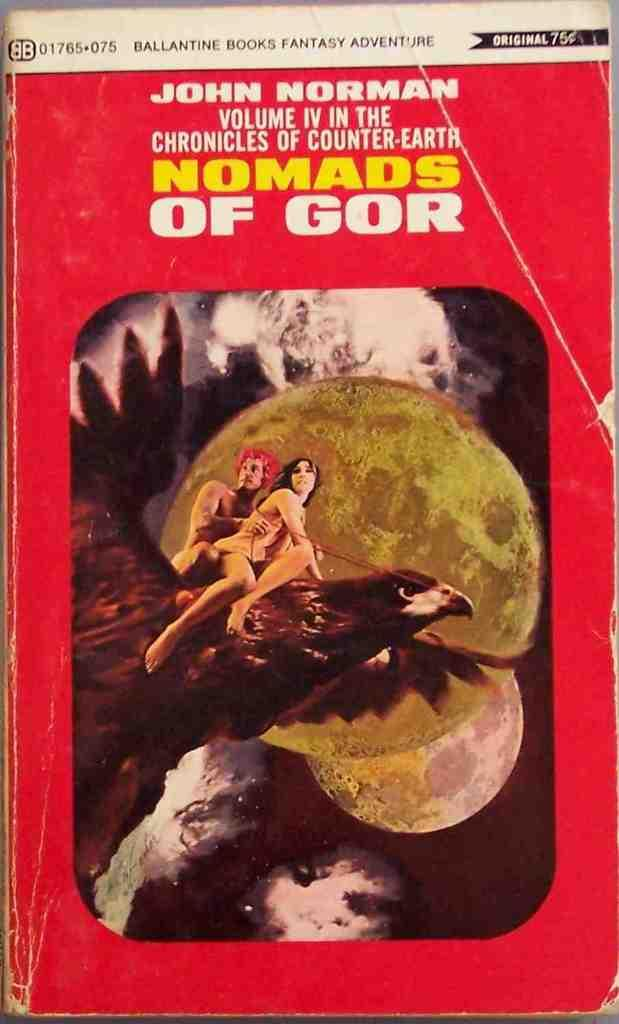<image>
Relay a brief, clear account of the picture shown. A naked man and woman ride a giant hawk on the cover of a book called Nomads Of Gor 